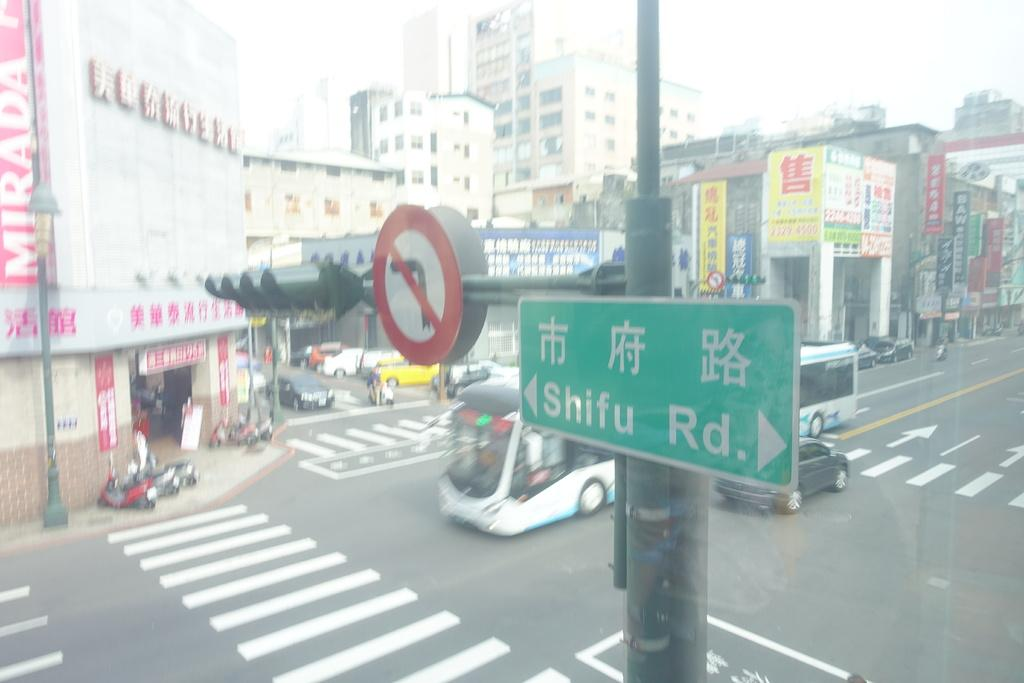<image>
Describe the image concisely. The road sign show here in green Shifu Rd 